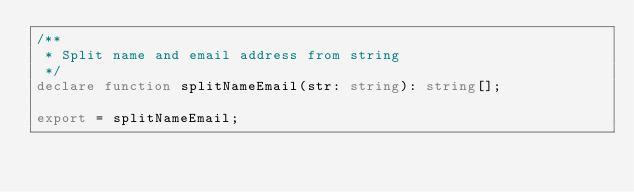<code> <loc_0><loc_0><loc_500><loc_500><_TypeScript_>/**
 * Split name and email address from string
 */
declare function splitNameEmail(str: string): string[];

export = splitNameEmail;</code> 